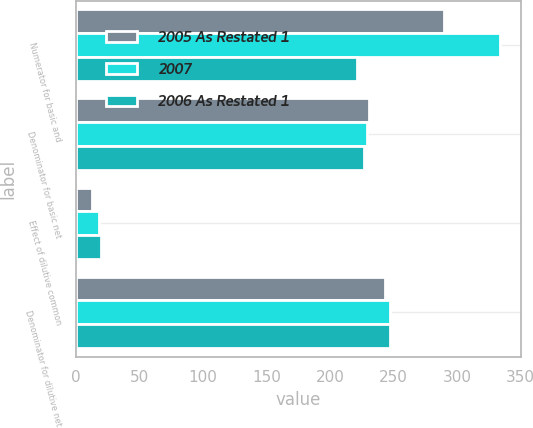Convert chart. <chart><loc_0><loc_0><loc_500><loc_500><stacked_bar_chart><ecel><fcel>Numerator for basic and<fcel>Denominator for basic net<fcel>Effect of dilutive common<fcel>Denominator for dilutive net<nl><fcel>2005 As Restated 1<fcel>289.7<fcel>230.7<fcel>12.5<fcel>243.2<nl><fcel>2007<fcel>333.6<fcel>229<fcel>18.5<fcel>247.5<nl><fcel>2006 As Restated 1<fcel>221.1<fcel>227<fcel>20<fcel>247<nl></chart> 